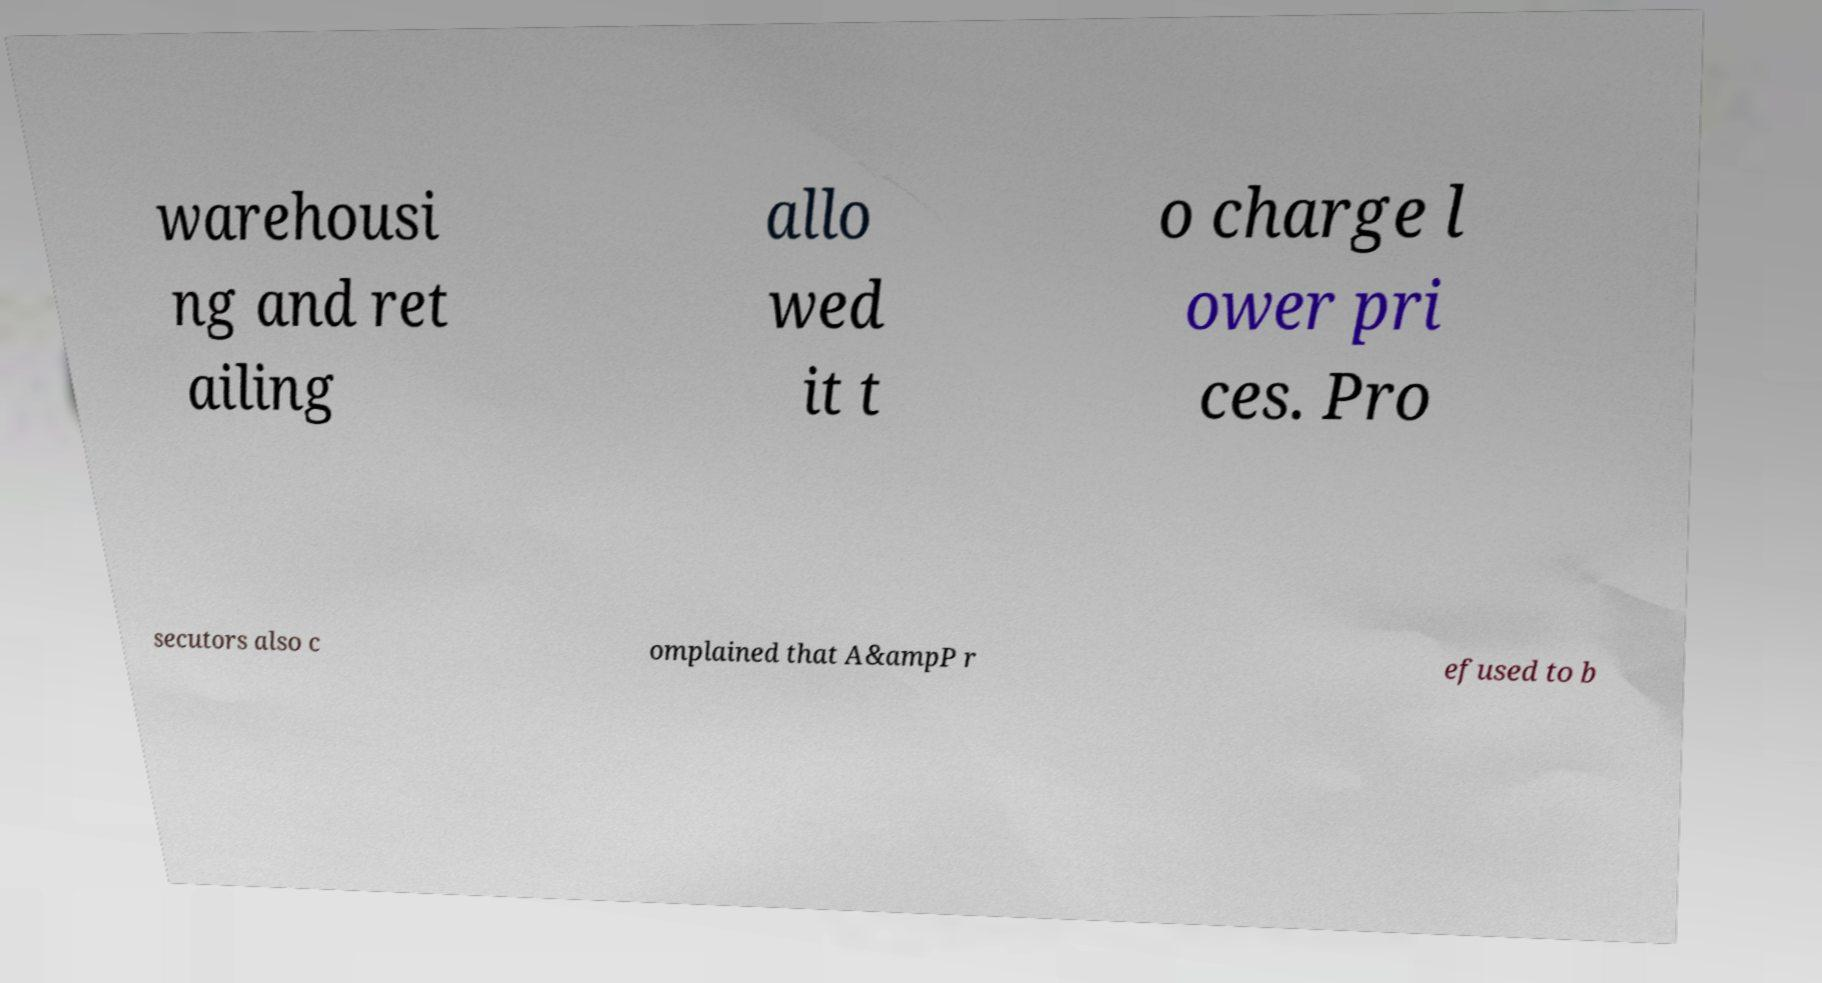Can you accurately transcribe the text from the provided image for me? warehousi ng and ret ailing allo wed it t o charge l ower pri ces. Pro secutors also c omplained that A&ampP r efused to b 